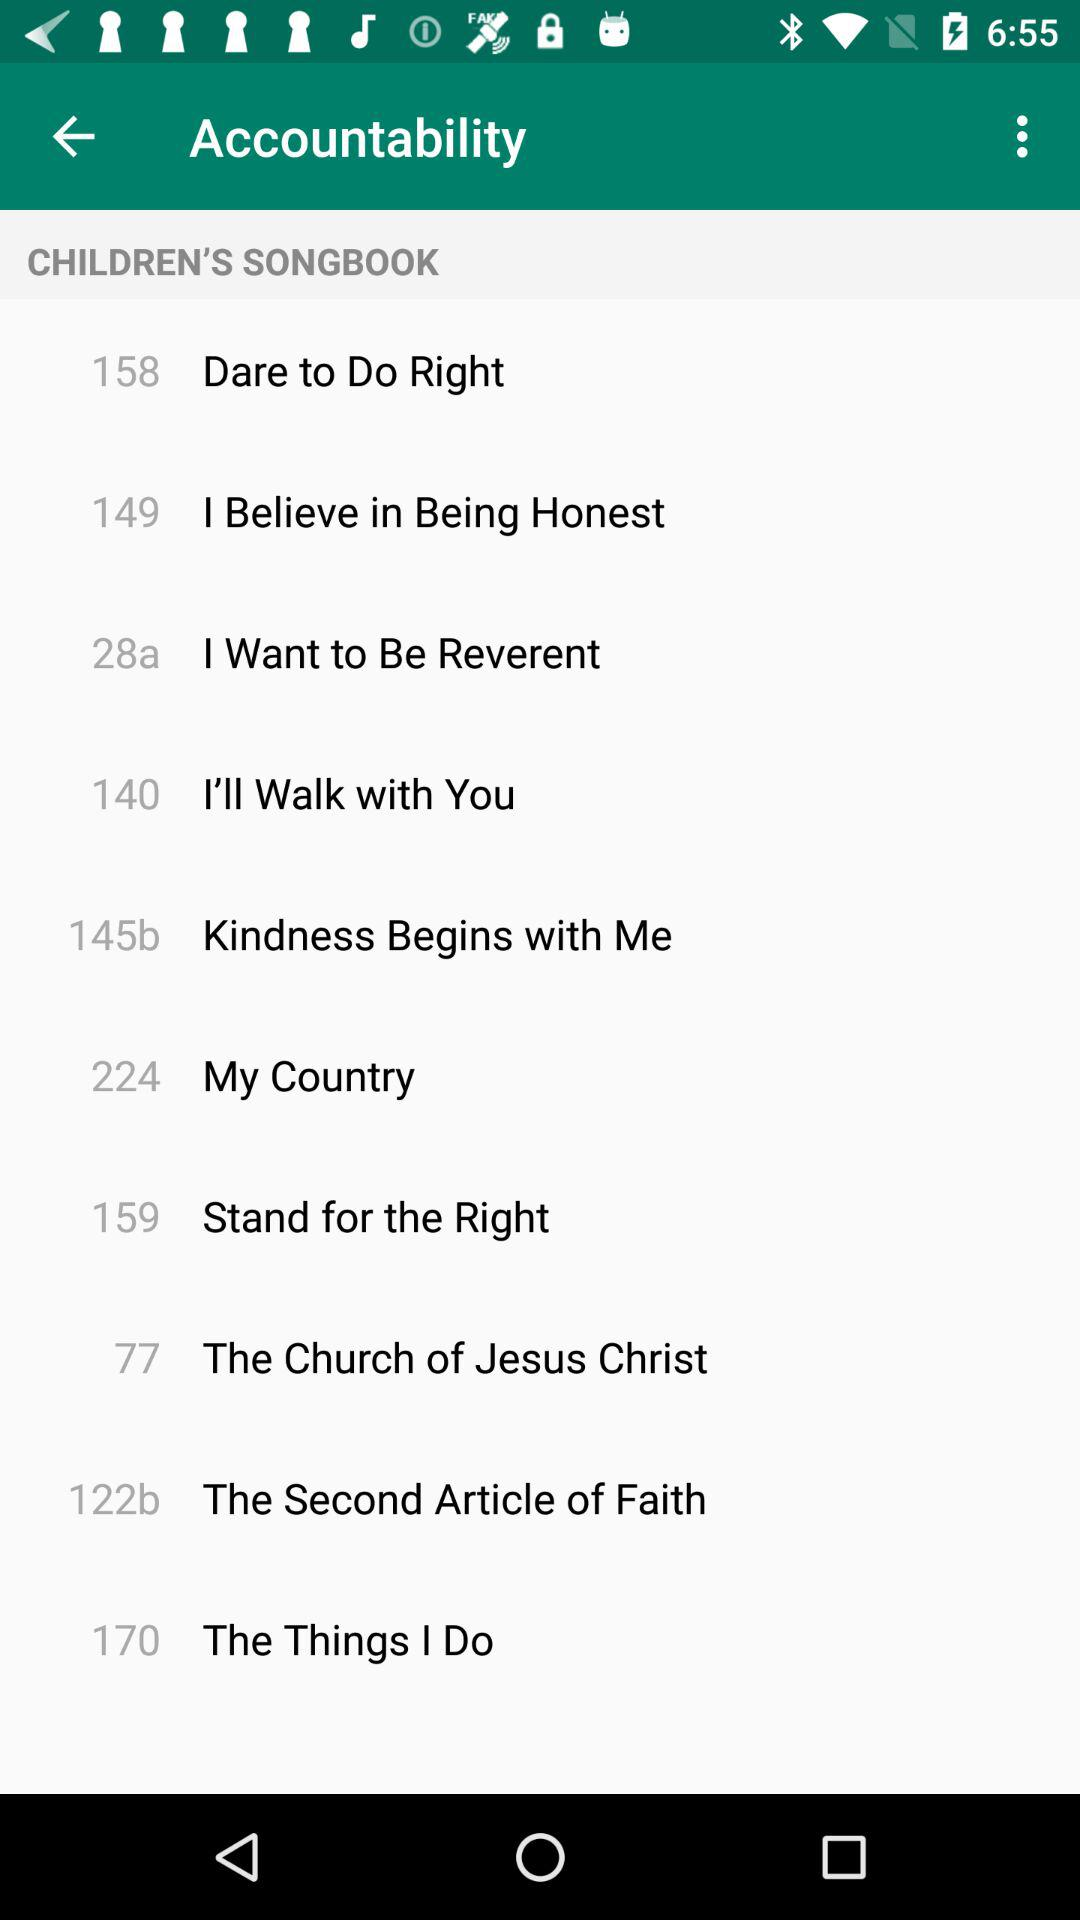Which song is on page number 77? The song on page number 77 is "The Church of Jesus Christ". 